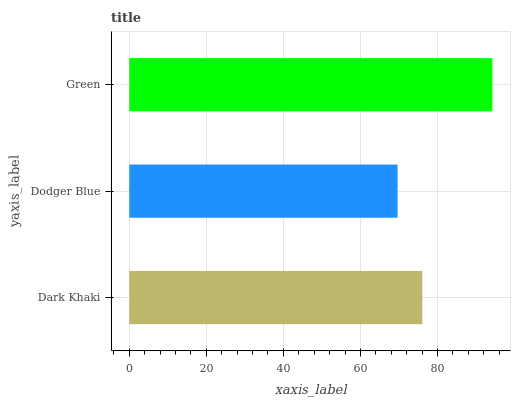Is Dodger Blue the minimum?
Answer yes or no. Yes. Is Green the maximum?
Answer yes or no. Yes. Is Green the minimum?
Answer yes or no. No. Is Dodger Blue the maximum?
Answer yes or no. No. Is Green greater than Dodger Blue?
Answer yes or no. Yes. Is Dodger Blue less than Green?
Answer yes or no. Yes. Is Dodger Blue greater than Green?
Answer yes or no. No. Is Green less than Dodger Blue?
Answer yes or no. No. Is Dark Khaki the high median?
Answer yes or no. Yes. Is Dark Khaki the low median?
Answer yes or no. Yes. Is Dodger Blue the high median?
Answer yes or no. No. Is Green the low median?
Answer yes or no. No. 